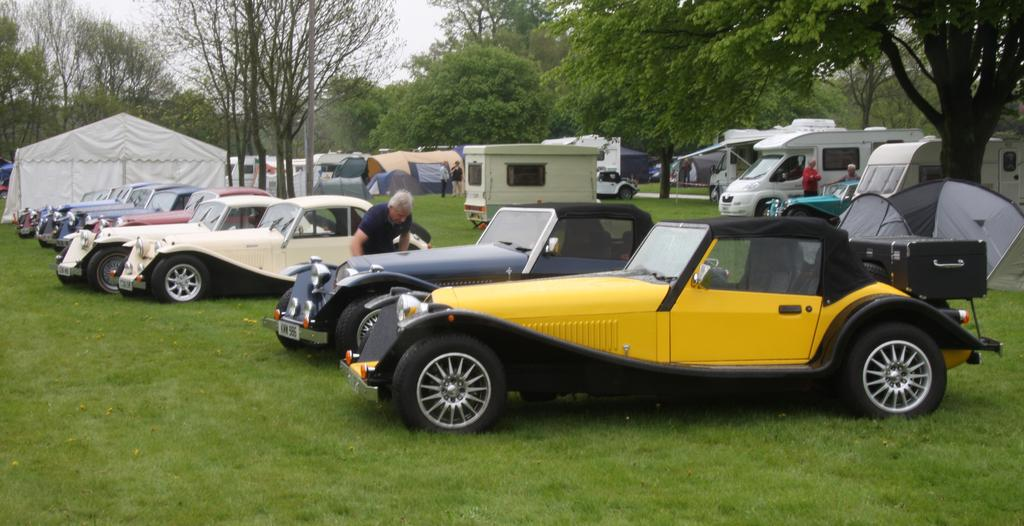What is the main subject of the image? The main subject of the image is many vehicles. Can you describe the man standing in the center of the image? There is a man standing in the center of the image. What can be seen in the background of the image? There is a tent and trees in the background of the image, as well as the sky. Can you see a rifle in the image? There is no rifle present in the image. 